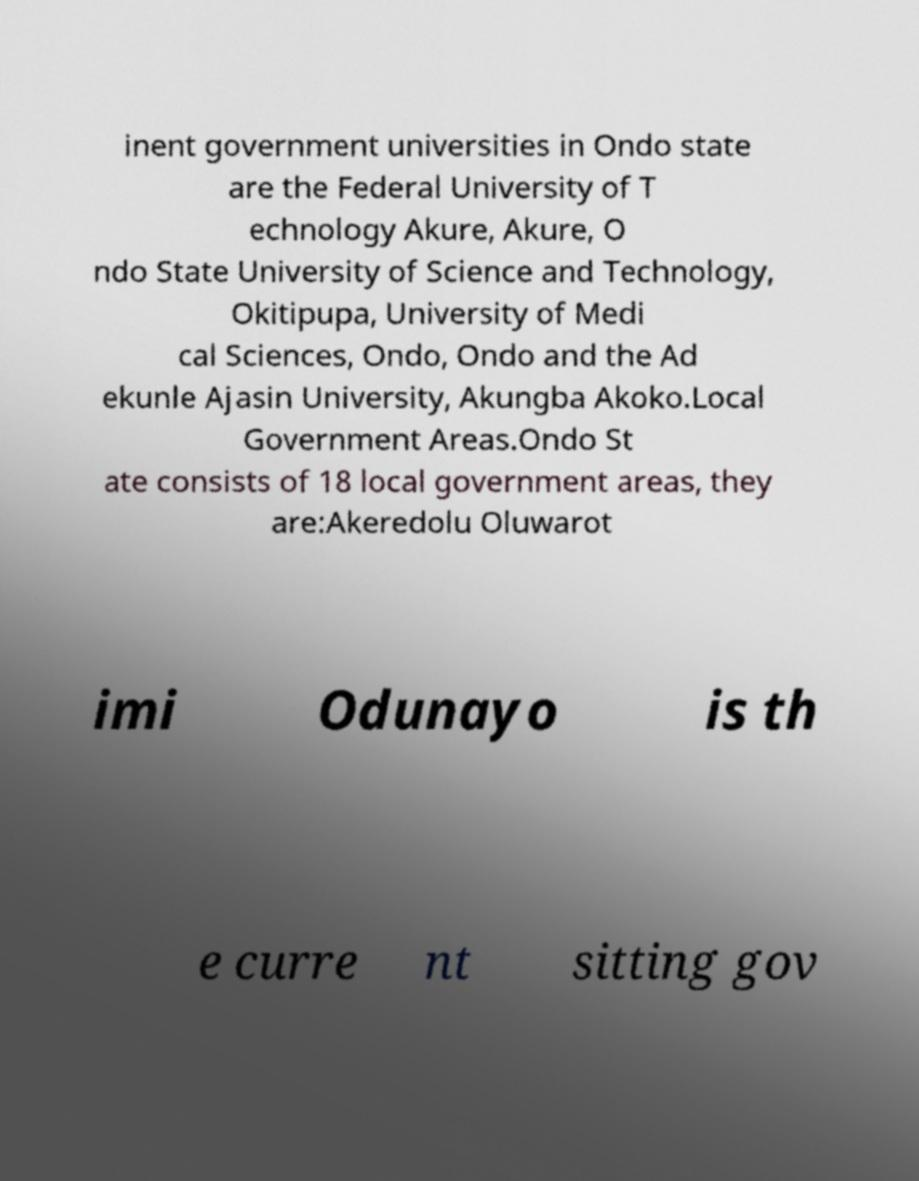Can you accurately transcribe the text from the provided image for me? inent government universities in Ondo state are the Federal University of T echnology Akure, Akure, O ndo State University of Science and Technology, Okitipupa, University of Medi cal Sciences, Ondo, Ondo and the Ad ekunle Ajasin University, Akungba Akoko.Local Government Areas.Ondo St ate consists of 18 local government areas, they are:Akeredolu Oluwarot imi Odunayo is th e curre nt sitting gov 